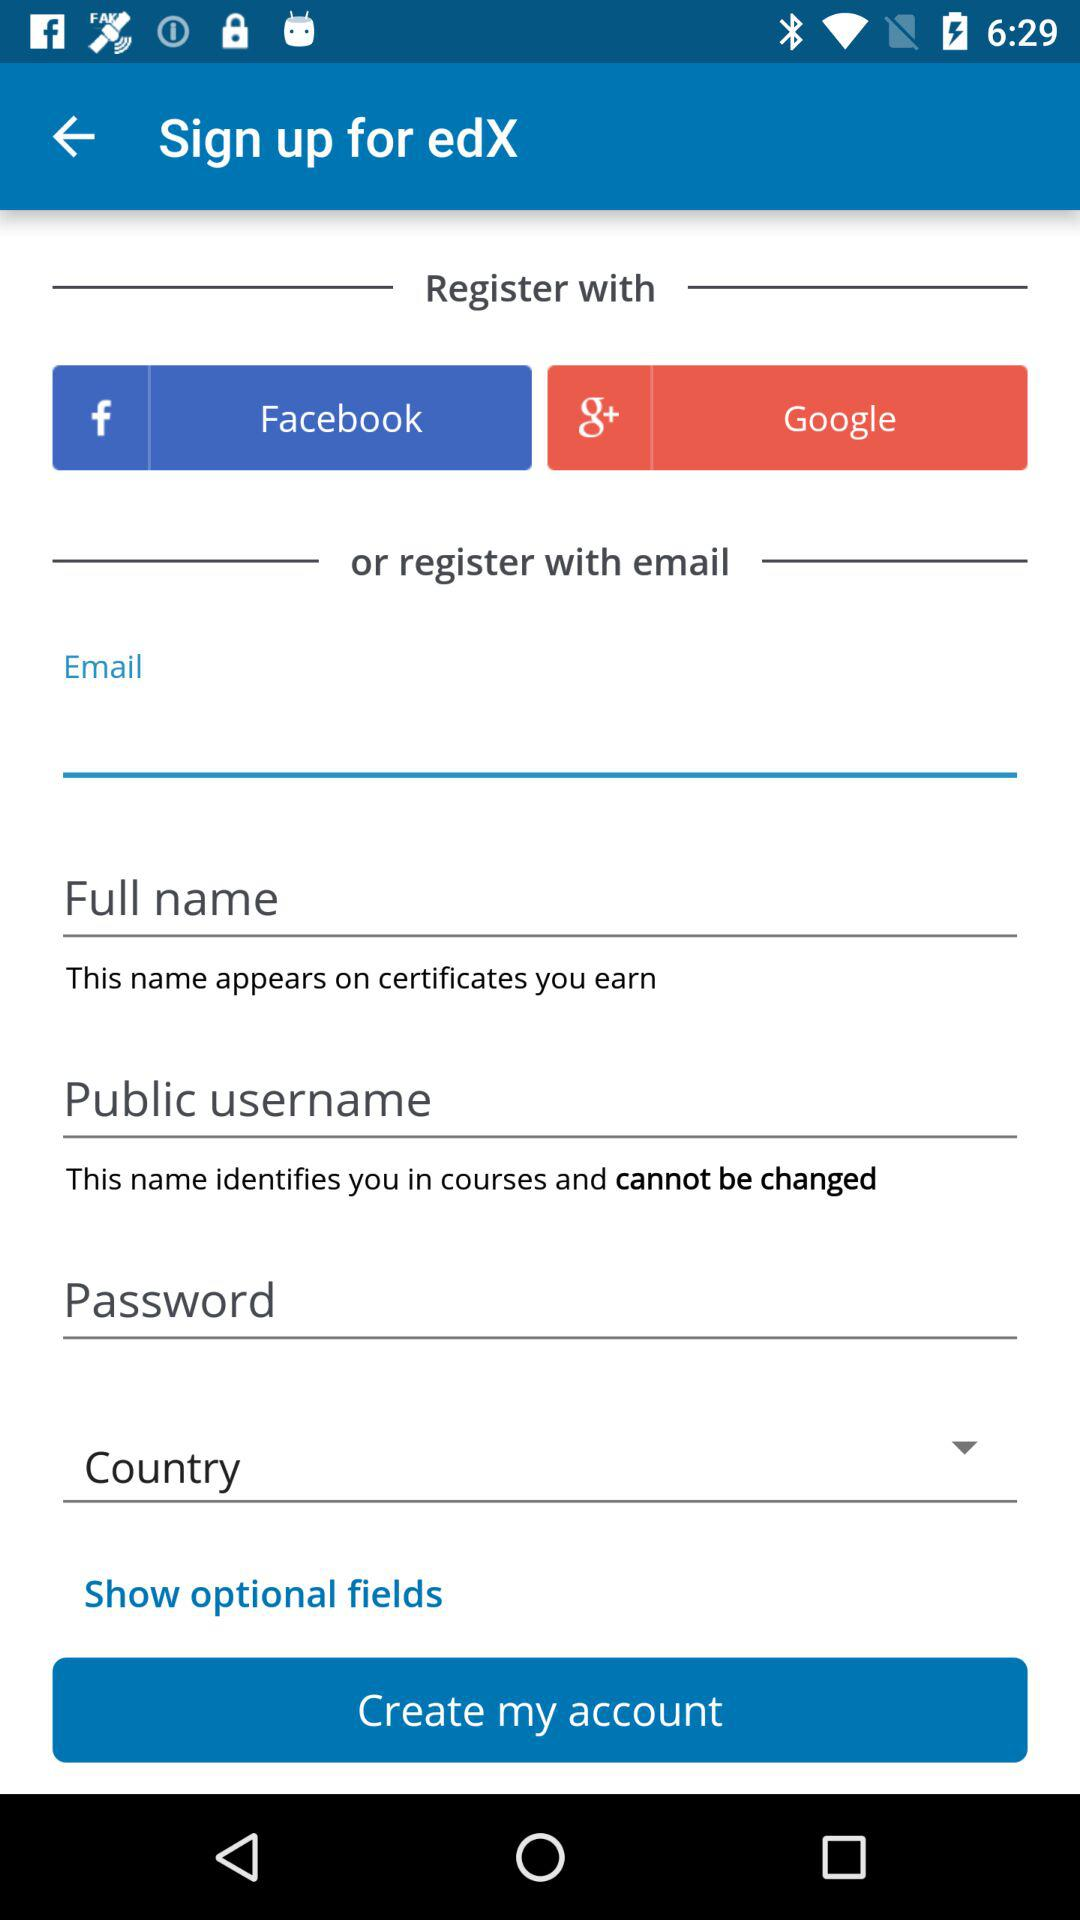What is the app name? The app name is "edX". 